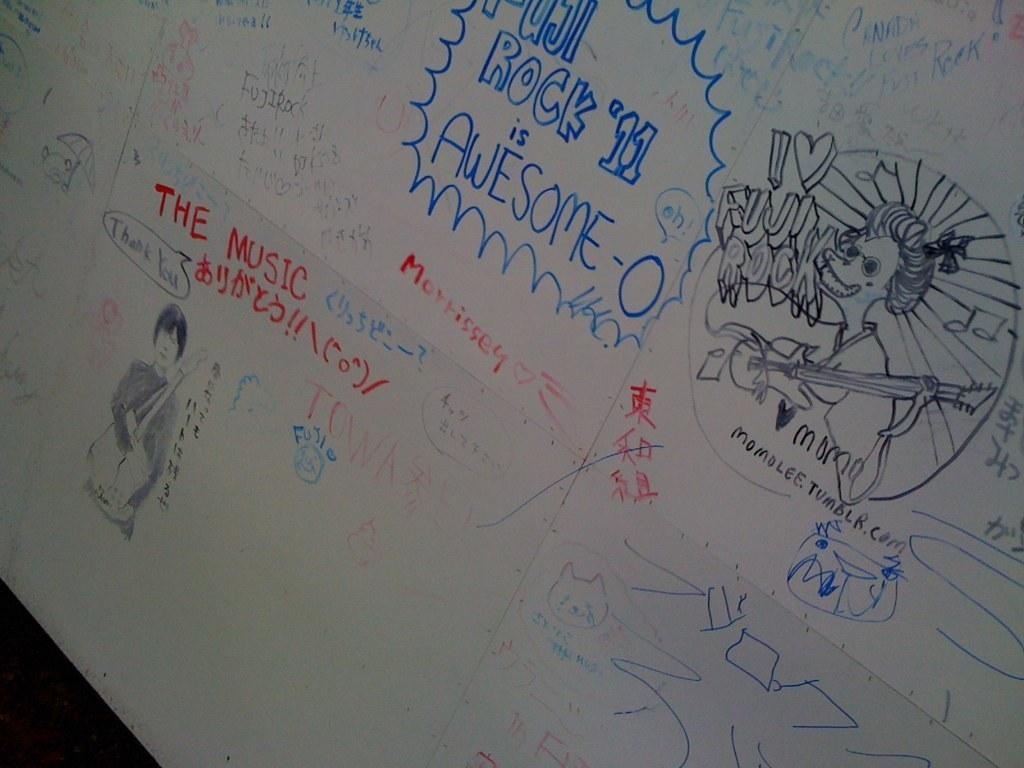<image>
Render a clear and concise summary of the photo. A whiteboard has several drawings of musicians for Fuji Rock. 